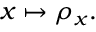Convert formula to latex. <formula><loc_0><loc_0><loc_500><loc_500>x \mapsto \rho _ { x } .</formula> 